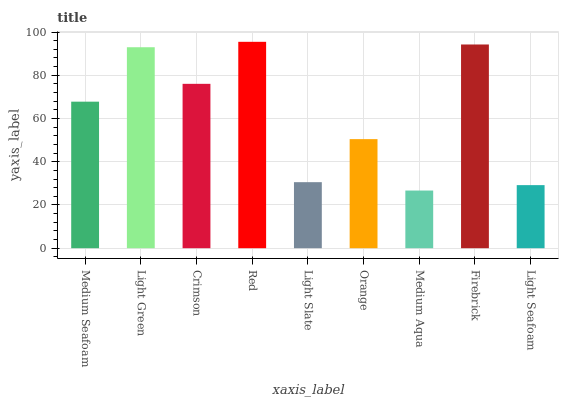Is Light Green the minimum?
Answer yes or no. No. Is Light Green the maximum?
Answer yes or no. No. Is Light Green greater than Medium Seafoam?
Answer yes or no. Yes. Is Medium Seafoam less than Light Green?
Answer yes or no. Yes. Is Medium Seafoam greater than Light Green?
Answer yes or no. No. Is Light Green less than Medium Seafoam?
Answer yes or no. No. Is Medium Seafoam the high median?
Answer yes or no. Yes. Is Medium Seafoam the low median?
Answer yes or no. Yes. Is Light Green the high median?
Answer yes or no. No. Is Medium Aqua the low median?
Answer yes or no. No. 